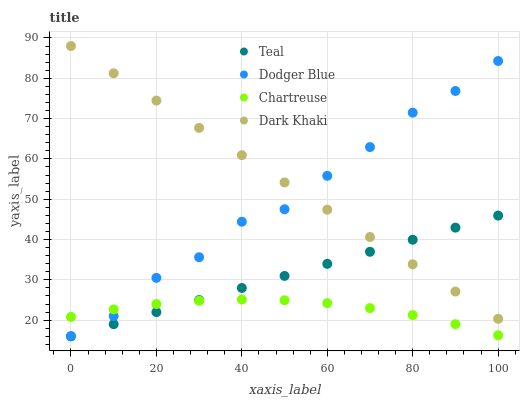Does Chartreuse have the minimum area under the curve?
Answer yes or no. Yes. Does Dark Khaki have the maximum area under the curve?
Answer yes or no. Yes. Does Dodger Blue have the minimum area under the curve?
Answer yes or no. No. Does Dodger Blue have the maximum area under the curve?
Answer yes or no. No. Is Teal the smoothest?
Answer yes or no. Yes. Is Dodger Blue the roughest?
Answer yes or no. Yes. Is Chartreuse the smoothest?
Answer yes or no. No. Is Chartreuse the roughest?
Answer yes or no. No. Does Dodger Blue have the lowest value?
Answer yes or no. Yes. Does Chartreuse have the lowest value?
Answer yes or no. No. Does Dark Khaki have the highest value?
Answer yes or no. Yes. Does Dodger Blue have the highest value?
Answer yes or no. No. Is Chartreuse less than Dark Khaki?
Answer yes or no. Yes. Is Dark Khaki greater than Chartreuse?
Answer yes or no. Yes. Does Teal intersect Chartreuse?
Answer yes or no. Yes. Is Teal less than Chartreuse?
Answer yes or no. No. Is Teal greater than Chartreuse?
Answer yes or no. No. Does Chartreuse intersect Dark Khaki?
Answer yes or no. No. 